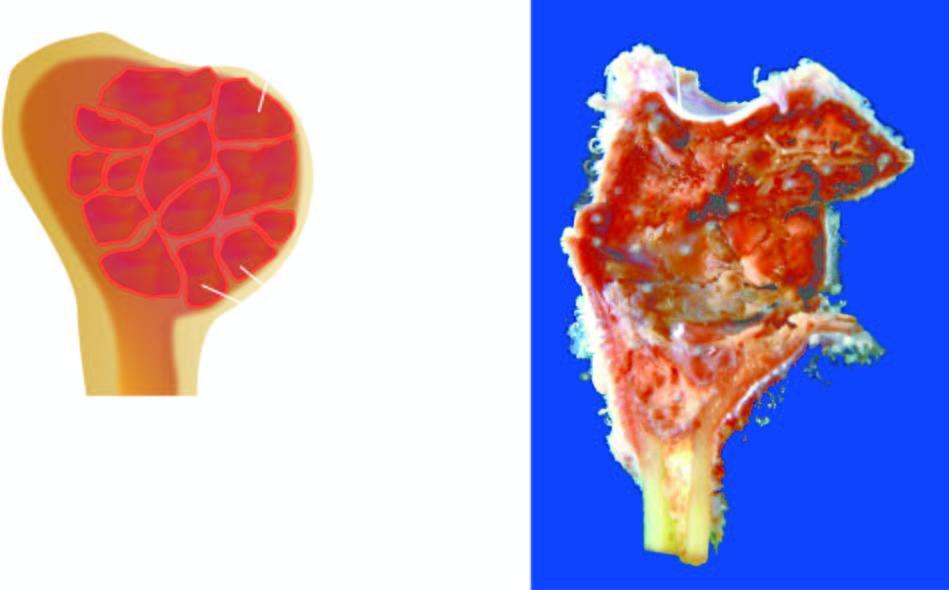s extension of fibrous tan and haemorrhagic?
Answer the question using a single word or phrase. No 